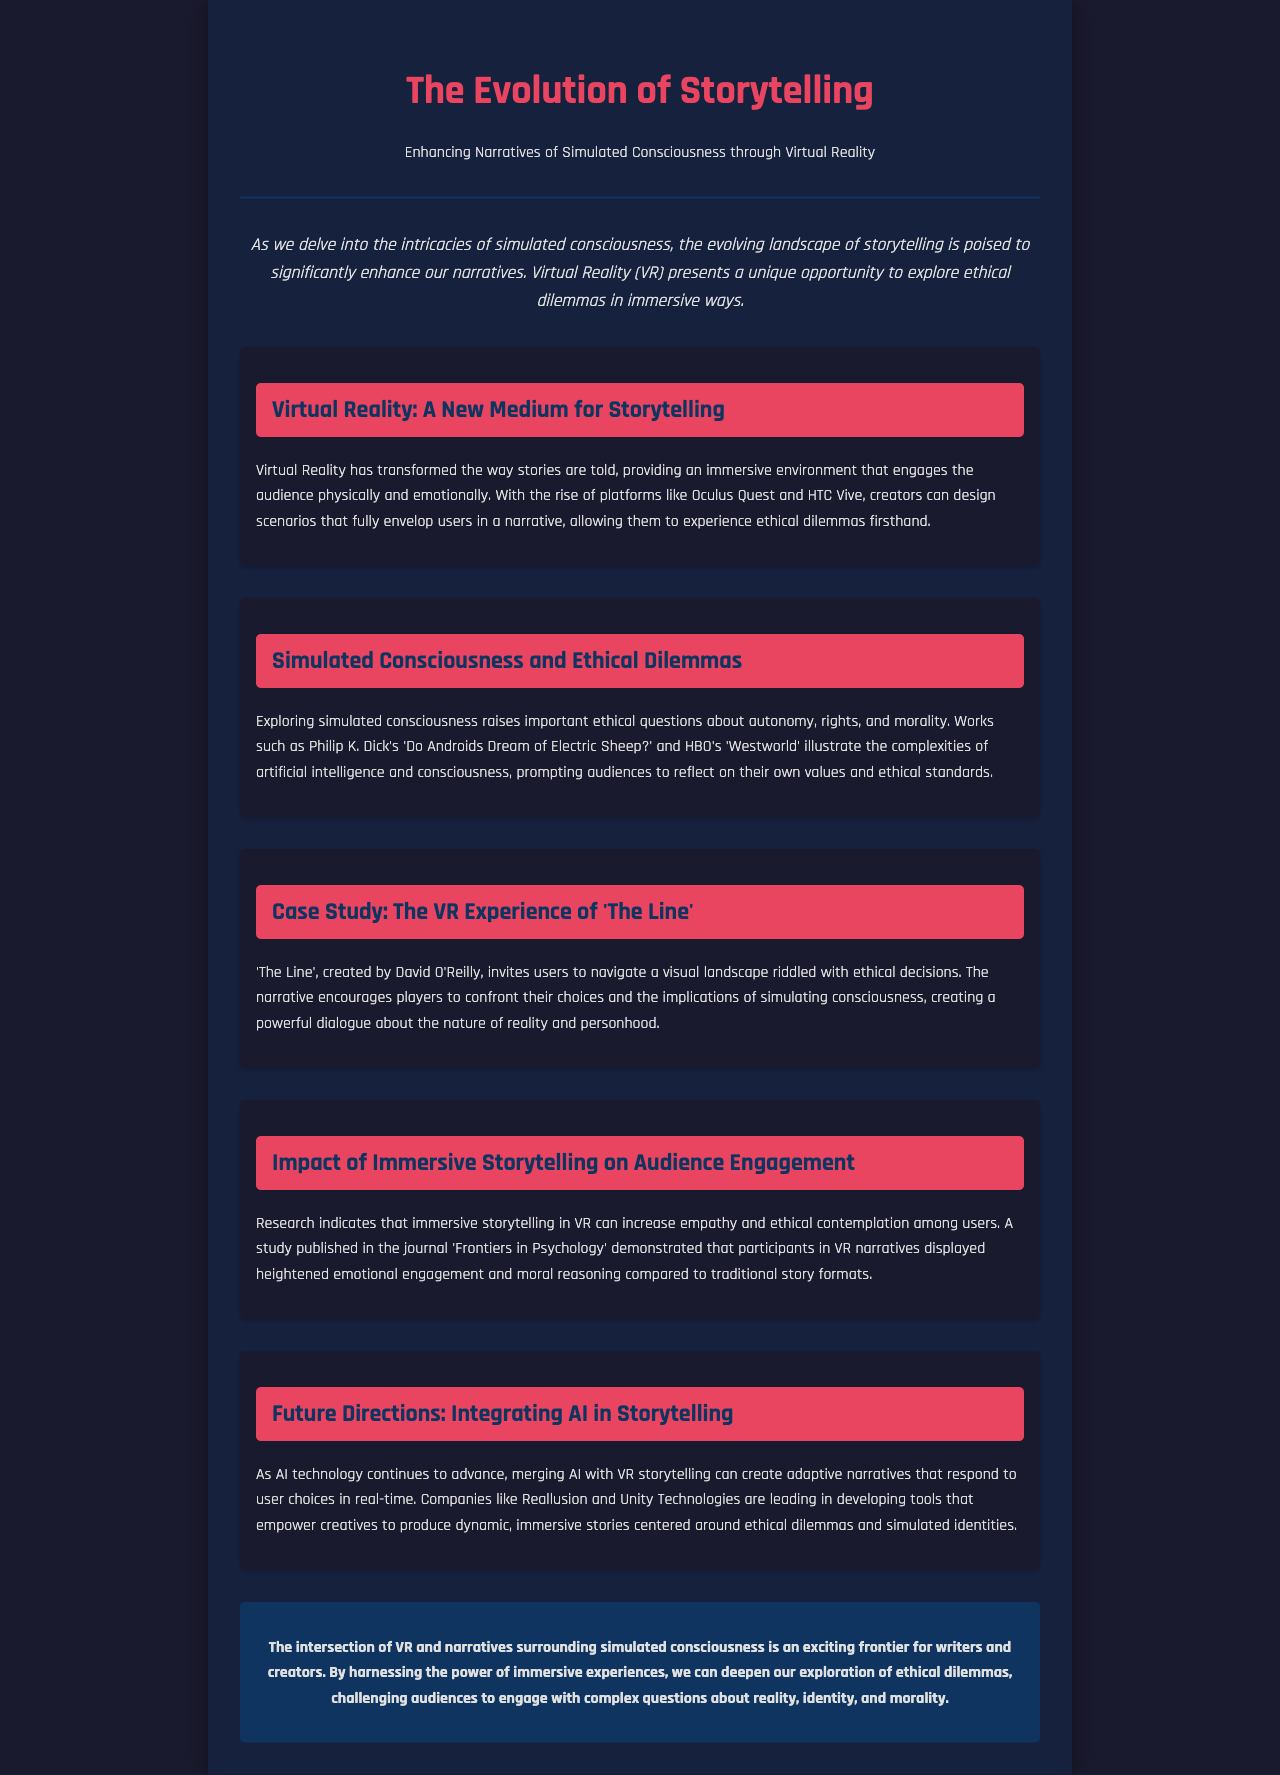What is the main focus of the newsletter? The newsletter's primary focus is on how virtual reality enhances narratives around simulated consciousness and ethical dilemmas.
Answer: virtual reality What medium is mentioned as transforming storytelling? The document highlights Virtual Reality (VR) as a new medium that transforms the way stories are told.
Answer: Virtual Reality (VR) Name the case study highlighted in the newsletter. The newsletter features 'The Line' as a case study that illustrates ethical decisions in a VR context.
Answer: 'The Line' Who created the VR experience 'The Line'? David O'Reilly is credited with creating the VR experience 'The Line'.
Answer: David O'Reilly Which two platforms are mentioned as examples for VR storytelling? The newsletter mentions Oculus Quest and HTC Vive as examples of platforms for VR storytelling.
Answer: Oculus Quest and HTC Vive What ethical questions are raised by simulated consciousness according to the document? The document states that simulated consciousness raises important ethical questions about autonomy, rights, and morality.
Answer: autonomy, rights, and morality Which study is referenced regarding immersive storytelling? The newsletter references a study published in the journal 'Frontiers in Psychology' related to immersive storytelling in VR.
Answer: 'Frontiers in Psychology' What is the future direction mentioned for storytelling? The document suggests that future storytelling may involve integrating AI with VR to create adaptive narratives.
Answer: integrating AI What is the conclusion of the newsletter regarding VR and storytelling? The conclusion emphasizes that the intersection of VR and narratives surrounding simulated consciousness is an exciting frontier for writers and creators.
Answer: exciting frontier 